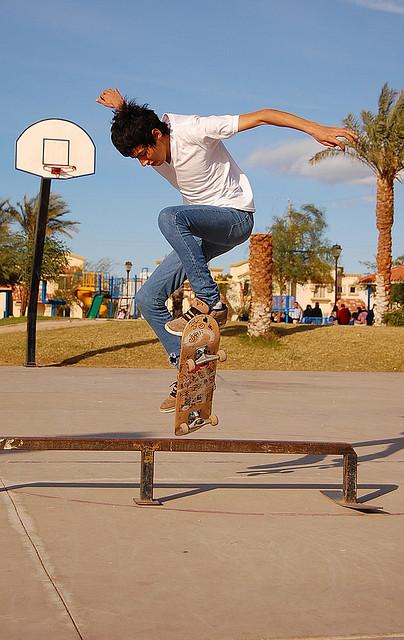Could I play basketball here?
Concise answer only. Yes. What trick is the man performing?
Write a very short answer. Jump. Can the man get injured?
Short answer required. Yes. 